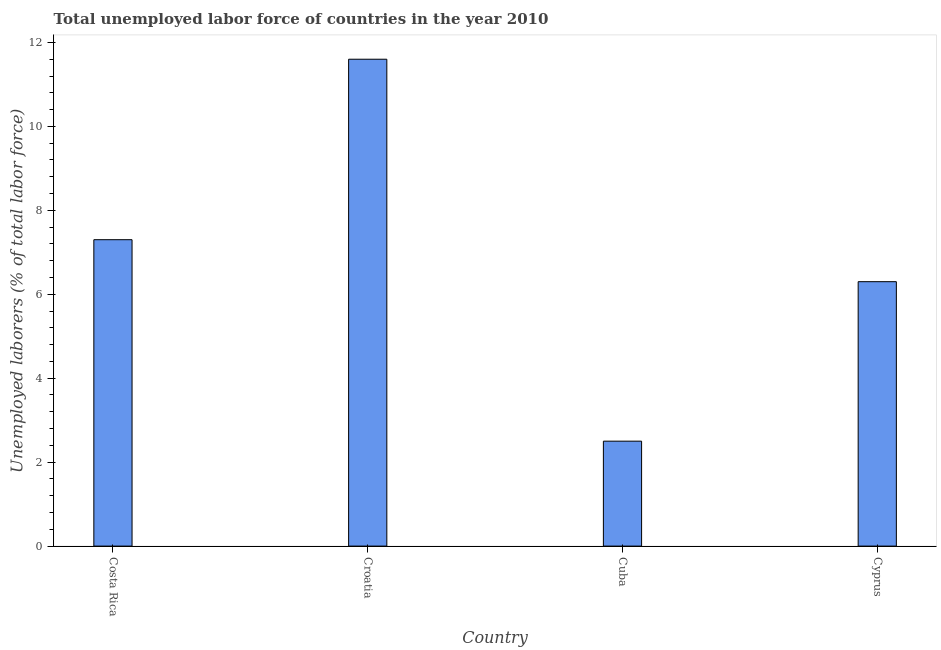Does the graph contain grids?
Offer a terse response. No. What is the title of the graph?
Provide a succinct answer. Total unemployed labor force of countries in the year 2010. What is the label or title of the Y-axis?
Ensure brevity in your answer.  Unemployed laborers (% of total labor force). Across all countries, what is the maximum total unemployed labour force?
Make the answer very short. 11.6. Across all countries, what is the minimum total unemployed labour force?
Your answer should be very brief. 2.5. In which country was the total unemployed labour force maximum?
Ensure brevity in your answer.  Croatia. In which country was the total unemployed labour force minimum?
Your answer should be very brief. Cuba. What is the sum of the total unemployed labour force?
Offer a very short reply. 27.7. What is the average total unemployed labour force per country?
Make the answer very short. 6.92. What is the median total unemployed labour force?
Offer a very short reply. 6.8. In how many countries, is the total unemployed labour force greater than 2.8 %?
Your answer should be very brief. 3. What is the ratio of the total unemployed labour force in Costa Rica to that in Cuba?
Ensure brevity in your answer.  2.92. Is the difference between the total unemployed labour force in Costa Rica and Cuba greater than the difference between any two countries?
Make the answer very short. No. What is the difference between the highest and the second highest total unemployed labour force?
Make the answer very short. 4.3. Is the sum of the total unemployed labour force in Croatia and Cyprus greater than the maximum total unemployed labour force across all countries?
Your answer should be very brief. Yes. What is the difference between the highest and the lowest total unemployed labour force?
Make the answer very short. 9.1. In how many countries, is the total unemployed labour force greater than the average total unemployed labour force taken over all countries?
Keep it short and to the point. 2. How many bars are there?
Keep it short and to the point. 4. How many countries are there in the graph?
Provide a succinct answer. 4. What is the Unemployed laborers (% of total labor force) in Costa Rica?
Offer a very short reply. 7.3. What is the Unemployed laborers (% of total labor force) of Croatia?
Provide a short and direct response. 11.6. What is the Unemployed laborers (% of total labor force) in Cuba?
Offer a very short reply. 2.5. What is the Unemployed laborers (% of total labor force) in Cyprus?
Provide a short and direct response. 6.3. What is the difference between the Unemployed laborers (% of total labor force) in Croatia and Cuba?
Give a very brief answer. 9.1. What is the difference between the Unemployed laborers (% of total labor force) in Cuba and Cyprus?
Your answer should be very brief. -3.8. What is the ratio of the Unemployed laborers (% of total labor force) in Costa Rica to that in Croatia?
Offer a very short reply. 0.63. What is the ratio of the Unemployed laborers (% of total labor force) in Costa Rica to that in Cuba?
Your answer should be very brief. 2.92. What is the ratio of the Unemployed laborers (% of total labor force) in Costa Rica to that in Cyprus?
Your answer should be compact. 1.16. What is the ratio of the Unemployed laborers (% of total labor force) in Croatia to that in Cuba?
Provide a succinct answer. 4.64. What is the ratio of the Unemployed laborers (% of total labor force) in Croatia to that in Cyprus?
Offer a very short reply. 1.84. What is the ratio of the Unemployed laborers (% of total labor force) in Cuba to that in Cyprus?
Make the answer very short. 0.4. 